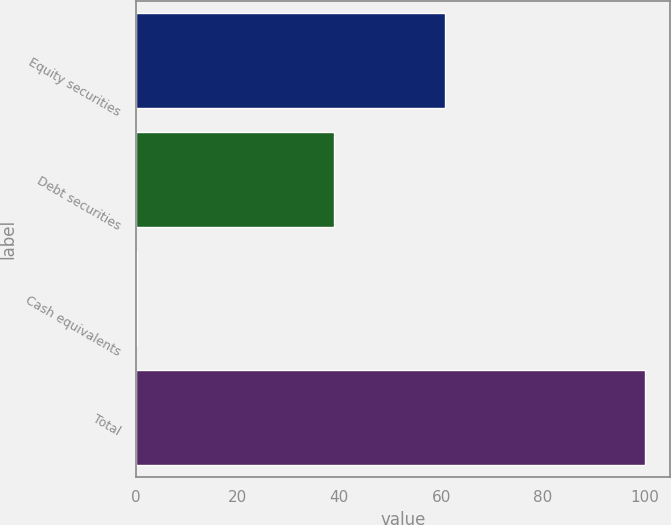Convert chart to OTSL. <chart><loc_0><loc_0><loc_500><loc_500><bar_chart><fcel>Equity securities<fcel>Debt securities<fcel>Cash equivalents<fcel>Total<nl><fcel>60.7<fcel>39<fcel>0.3<fcel>100<nl></chart> 